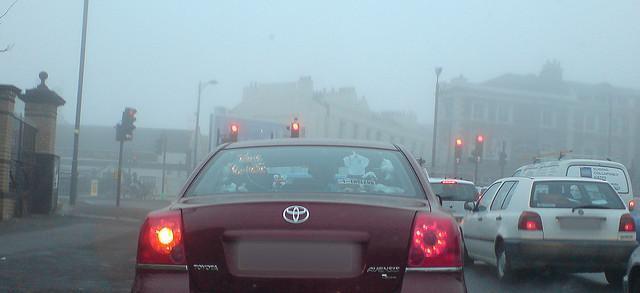How many cars are there?
Give a very brief answer. 3. 